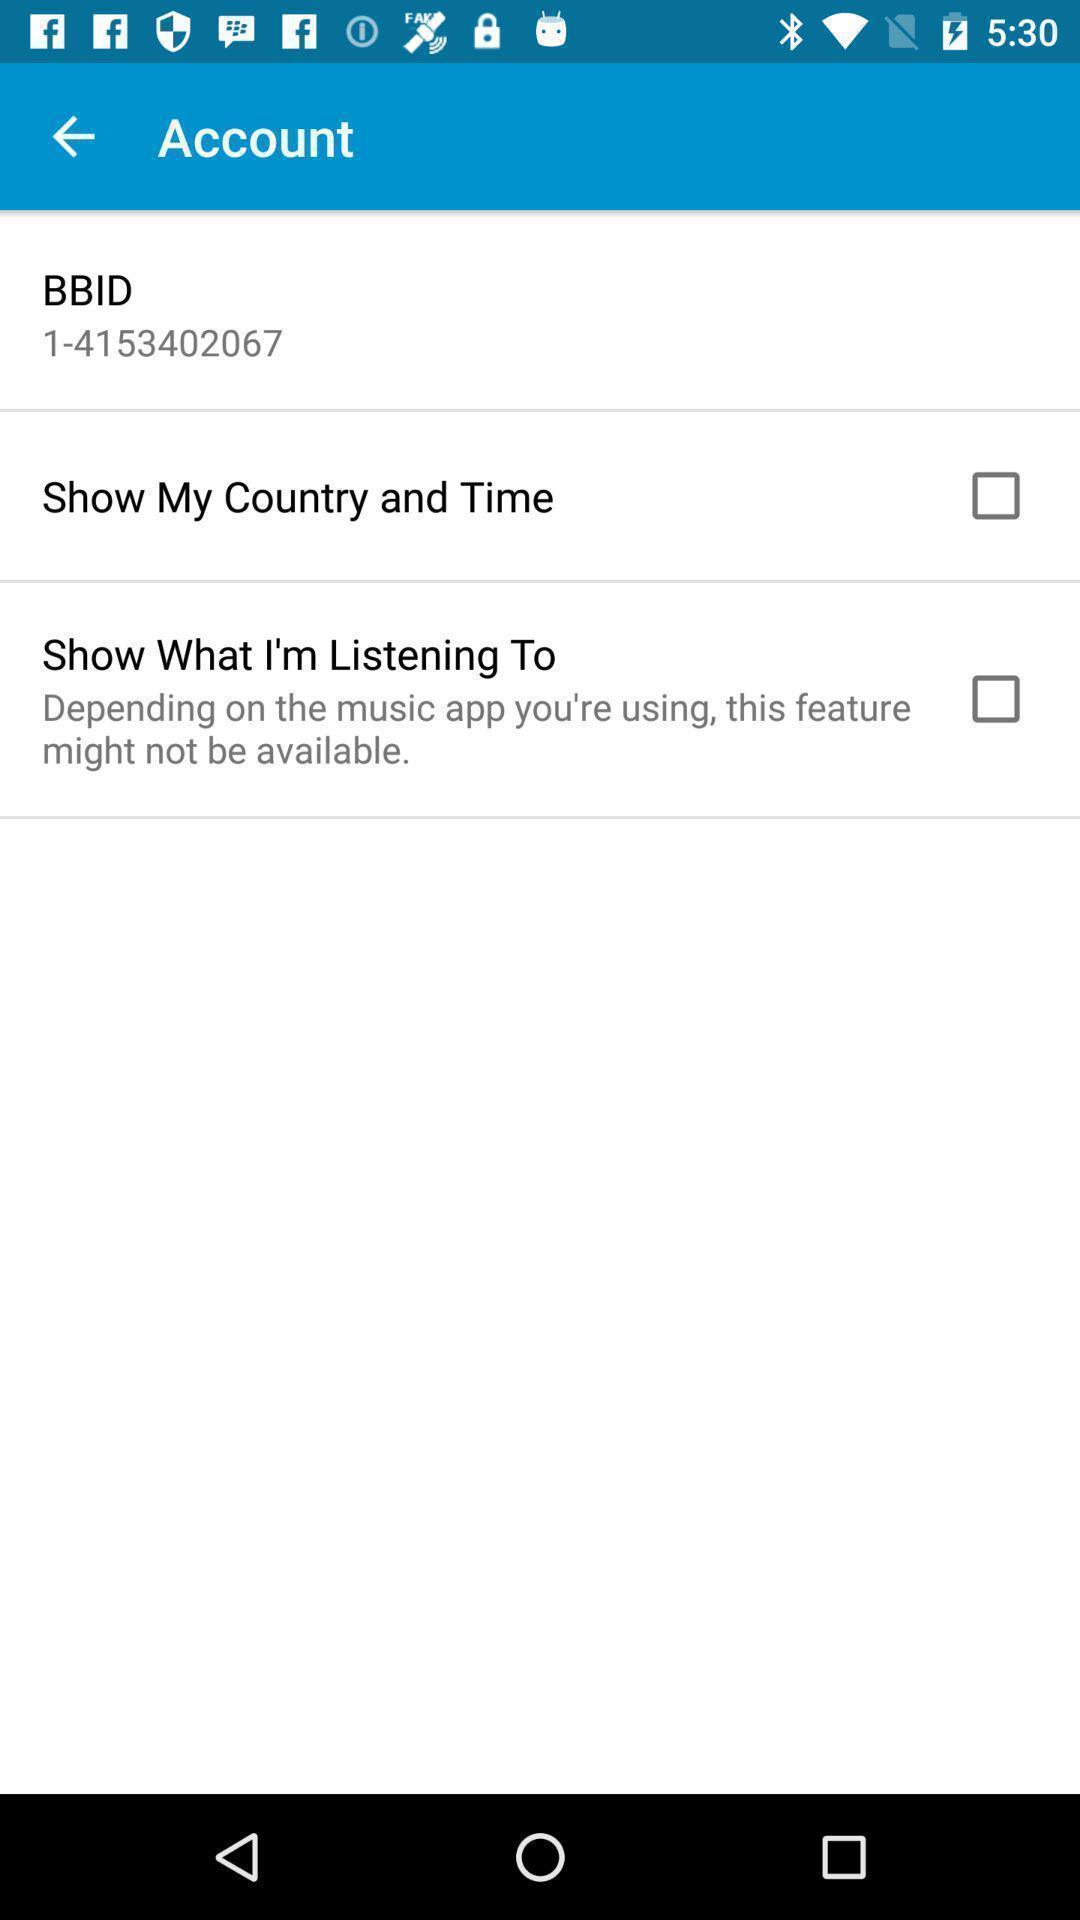Tell me about the visual elements in this screen capture. Screen showing options in accounts. 